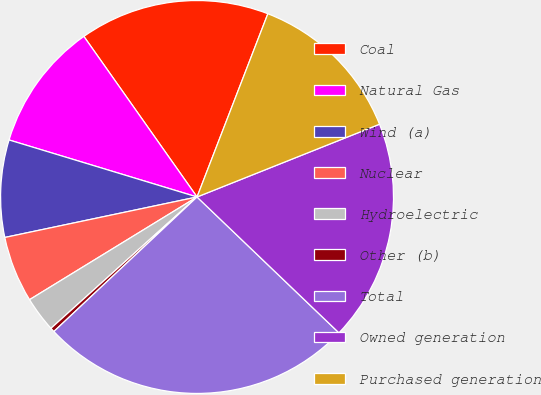Convert chart to OTSL. <chart><loc_0><loc_0><loc_500><loc_500><pie_chart><fcel>Coal<fcel>Natural Gas<fcel>Wind (a)<fcel>Nuclear<fcel>Hydroelectric<fcel>Other (b)<fcel>Total<fcel>Owned generation<fcel>Purchased generation<nl><fcel>15.64%<fcel>10.54%<fcel>7.99%<fcel>5.45%<fcel>2.9%<fcel>0.35%<fcel>25.84%<fcel>18.19%<fcel>13.09%<nl></chart> 